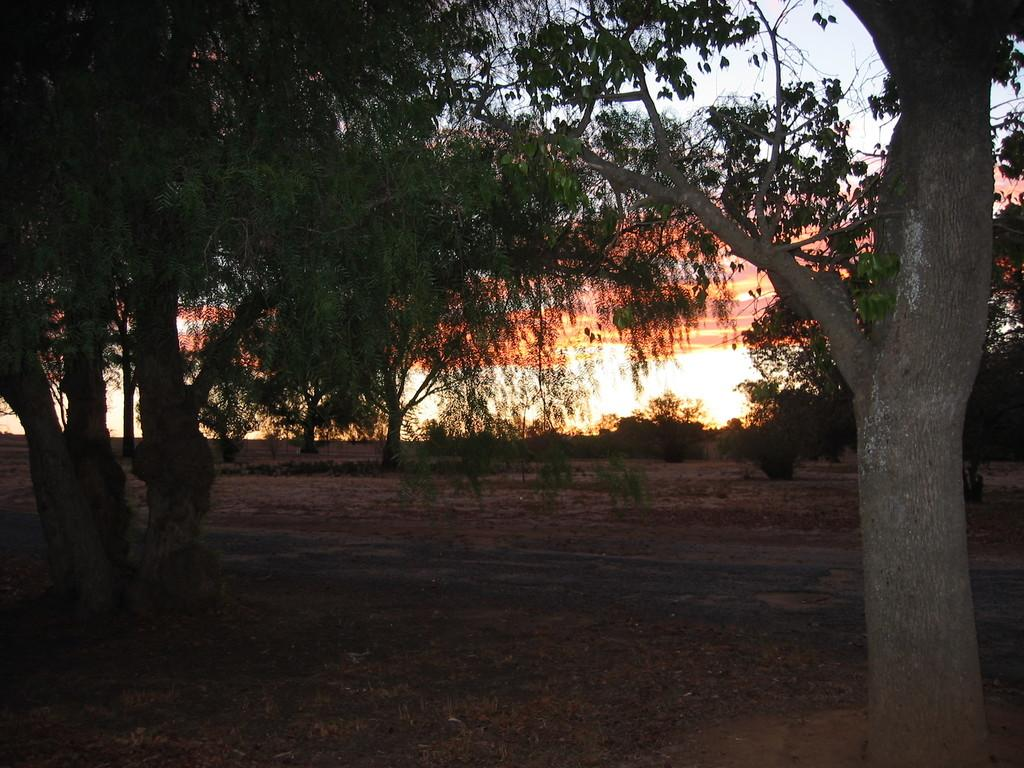What type of vegetation can be seen in the image? There are trees in the image. What part of the natural environment is visible in the image? The sky is visible in the background of the image. Where can the toothpaste be found in the image? There is no toothpaste present in the image. What type of organization is depicted in the image? There is no organization depicted in the image; it features trees and the sky. 